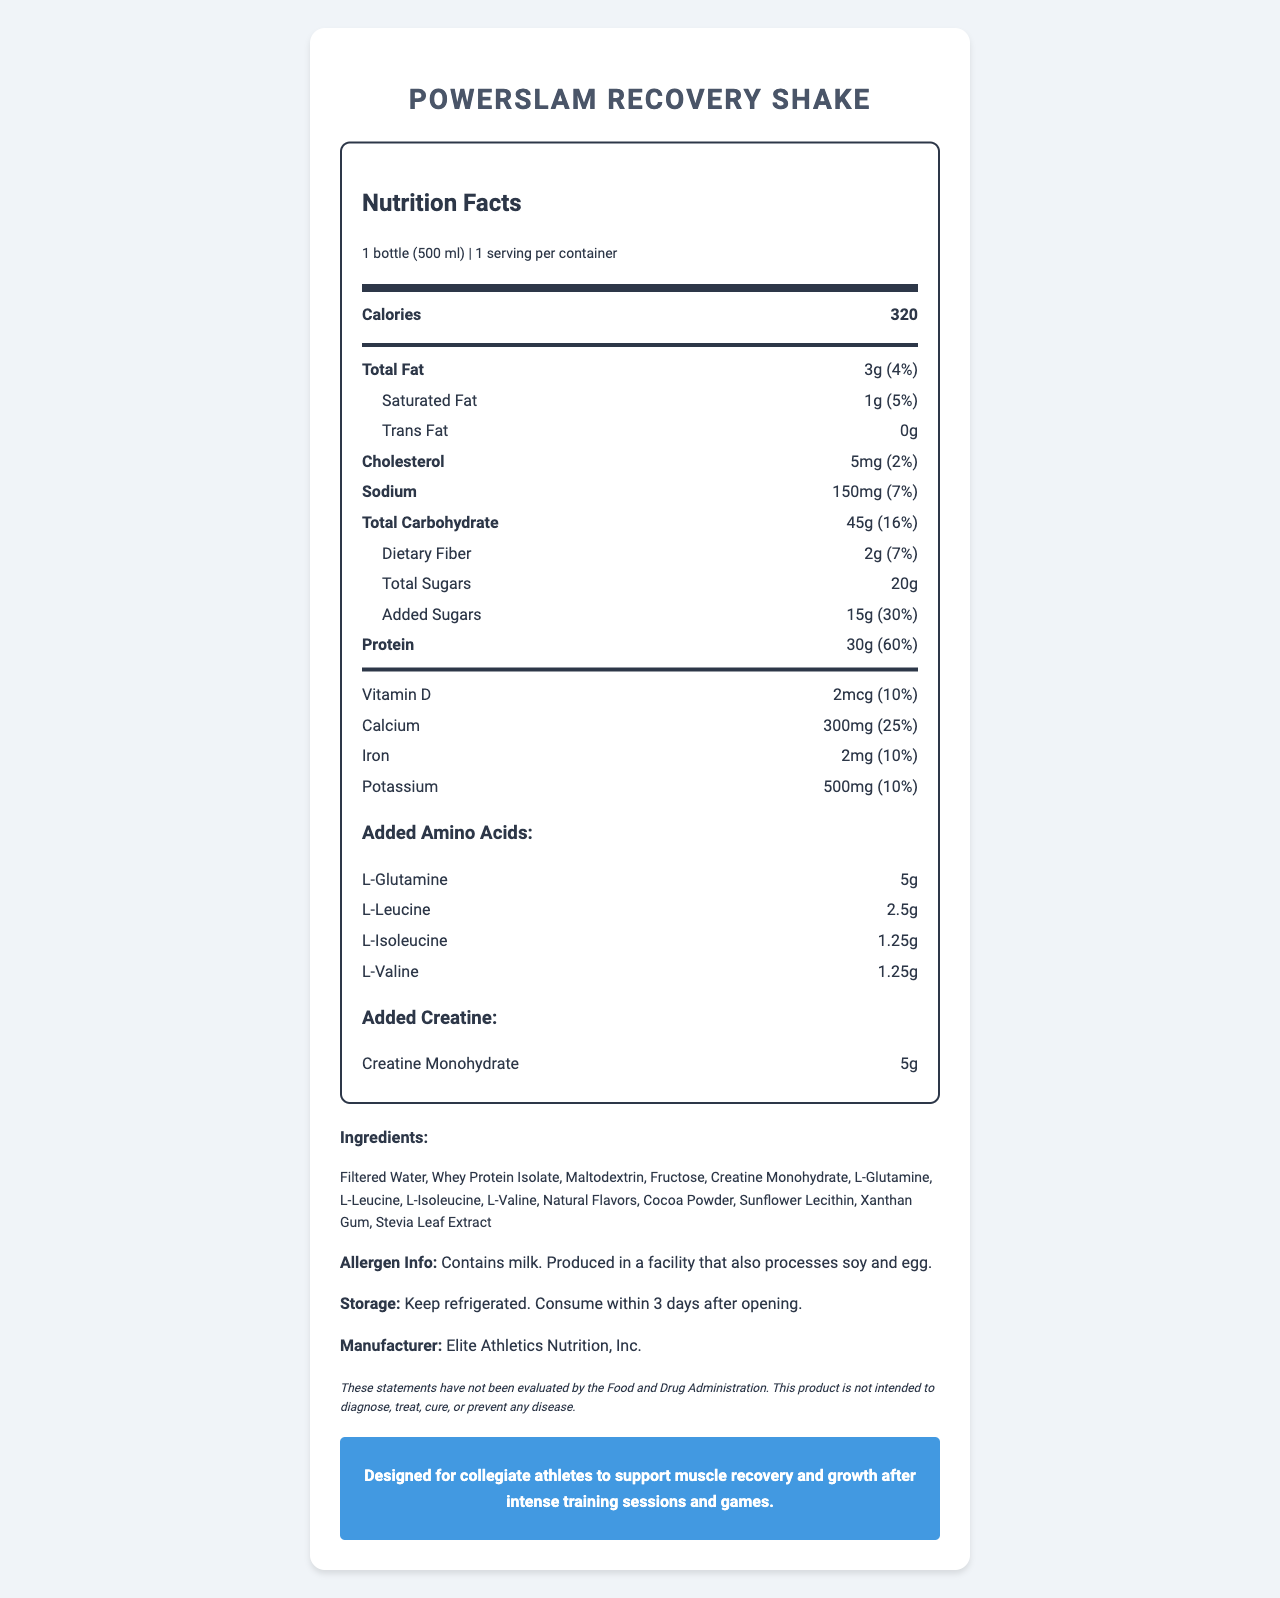What is the serving size of PowerSlam Recovery Shake? The serving size is clearly specified as 1 bottle (500 ml) in the nutrition label's description.
Answer: 1 bottle (500 ml) How many calories are in one serving? The label indicates that one serving of PowerSlam Recovery Shake contains 320 calories.
Answer: 320 What is the protein content in one serving, and what percentage of the daily value does it represent? The label shows that each serving contains 30g of protein, which represents 60% of the daily value.
Answer: 30g, 60% Which special ingredients are added to support muscle recovery and growth? The label mentions the addition of amino acids (L-Glutamine, L-Leucine, L-Isoleucine, L-Valine) and creatine monohydrate (5g) to support muscle recovery and growth.
Answer: Amino acids and creatine What are the storage instructions for PowerSlam Recovery Shake? The storage instructions on the label state to keep the product refrigerated and to consume within 3 days after opening.
Answer: Keep refrigerated. Consume within 3 days after opening. Which of the following fats is present in the PowerSlam Recovery Shake? A. Saturated Fat B. Unsaturated Fat C. Trans Fat The document specifies that the shake contains 1g of Saturated Fat (5%).
Answer: A. Saturated Fat Which ingredient is the primary protein source in the PowerSlam Recovery Shake? A. Soy Protein Isolate B. Whey Protein Isolate C. Casein Protein The ingredient list indicates that Whey Protein Isolate is the primary protein source.
Answer: B. Whey Protein Isolate Is the product suitable for someone with a milk allergy? The allergen information states that the product contains milk, making it unsuitable for someone with a milk allergy.
Answer: No Summarize the main idea of the PowerSlam Recovery Shake nutrition label. The label provides detailed information about the nutritional content, ingredients, and specific benefits of the shake, with a focus on supporting athletes' recovery.
Answer: The PowerSlam Recovery Shake is designed for collegiate athletes to support muscle recovery and growth. Each serving contains 320 calories, 30g of protein (60% daily value), and added amino acids and creatine. It contains key nutrients, including vitamins and minerals, and should be kept refrigerated and consumed within 3 days after opening. The product contains milk and is manufactured by Elite Athletics Nutrition, Inc. How many grams of dietary fiber are in one serving? The label lists the dietary fiber content as 2g per serving, which is 7% of the daily value.
Answer: 2g What is the amount of sodium in one serving of the shake, and what percentage of the daily value does it represent? The sodium content of the shake is 150mg, representing 7% of the daily value.
Answer: 150mg, 7% Which of the following amino acids is NOT mentioned in the nutrition label? I. L-Glutamine II. L-Leucine III. L-Tryptophan IV. L-Isoleucine The document lists L-Glutamine, L-Leucine, and L-Isoleucine, but not L-Tryptophan.
Answer: III. L-Tryptophan Can the nutrition content of PowerSlam Recovery Shake prevent diseases as per FDA evaluation? The disclaimer on the label indicates that these statements have not been evaluated by the FDA and that the product is not intended to diagnose, treat, cure, or prevent any disease.
Answer: No What flavoring agents are used in the PowerSlam Recovery Shake? The ingredients list includes Natural Flavors, Cocoa Powder, and Stevia Leaf Extract as flavoring agents.
Answer: Natural Flavors, Cocoa Powder, Stevia Leaf Extract What is the daily value percentage of Vitamin D provided by the shake? The label states that one serving contains 2mcg of Vitamin D, which is 10% of the daily value.
Answer: 10% Who is the manufacturer of the PowerSlam Recovery Shake? The document specifies that Elite Athletics Nutrition, Inc. is the manufacturer.
Answer: Elite Athletics Nutrition, Inc. Is the product free from soy and egg processing? The allergen information reveals that the product is produced in a facility that also processes soy and egg.
Answer: No What is the total amount of sugars, including added sugars, in one serving of the shake? The total sugars content is listed as 20g, which includes 15g of added sugars.
Answer: 20g total sugars, including 15g added sugars Which additional nutrient information is needed to assess the product's overall nutritional balance? The document does not provide information on other essential vitamins and minerals beyond Vitamin D, Calcium, Iron, and Potassium.
Answer: Essential vitamins and minerals not listed on the label like Vitamin C, B Vitamins, and Magnesium. 